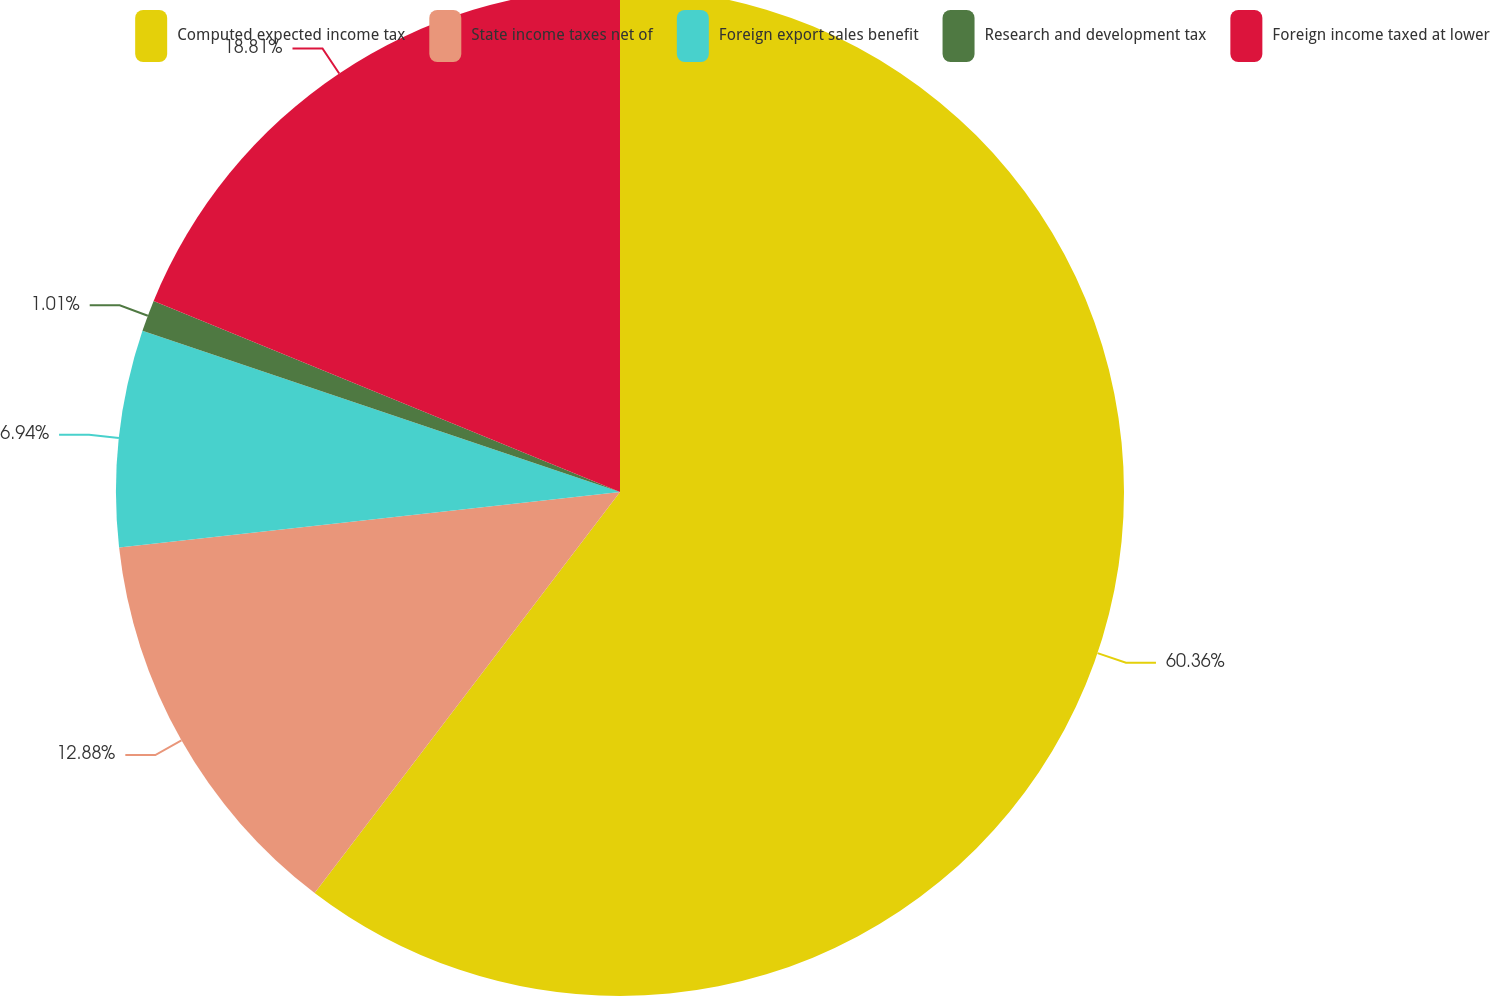Convert chart to OTSL. <chart><loc_0><loc_0><loc_500><loc_500><pie_chart><fcel>Computed expected income tax<fcel>State income taxes net of<fcel>Foreign export sales benefit<fcel>Research and development tax<fcel>Foreign income taxed at lower<nl><fcel>60.36%<fcel>12.88%<fcel>6.94%<fcel>1.01%<fcel>18.81%<nl></chart> 